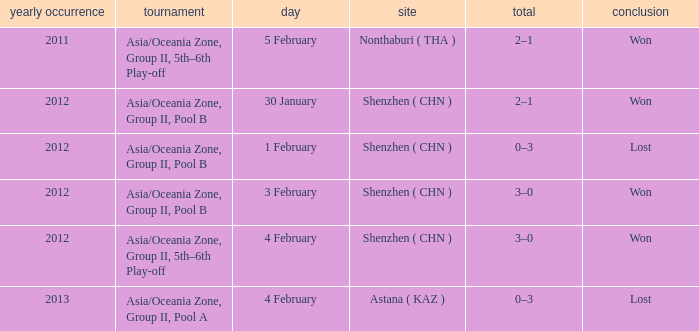What is the sum of the year for 5 february? 2011.0. Help me parse the entirety of this table. {'header': ['yearly occurrence', 'tournament', 'day', 'site', 'total', 'conclusion'], 'rows': [['2011', 'Asia/Oceania Zone, Group II, 5th–6th Play-off', '5 February', 'Nonthaburi ( THA )', '2–1', 'Won'], ['2012', 'Asia/Oceania Zone, Group II, Pool B', '30 January', 'Shenzhen ( CHN )', '2–1', 'Won'], ['2012', 'Asia/Oceania Zone, Group II, Pool B', '1 February', 'Shenzhen ( CHN )', '0–3', 'Lost'], ['2012', 'Asia/Oceania Zone, Group II, Pool B', '3 February', 'Shenzhen ( CHN )', '3–0', 'Won'], ['2012', 'Asia/Oceania Zone, Group II, 5th–6th Play-off', '4 February', 'Shenzhen ( CHN )', '3–0', 'Won'], ['2013', 'Asia/Oceania Zone, Group II, Pool A', '4 February', 'Astana ( KAZ )', '0–3', 'Lost']]} 